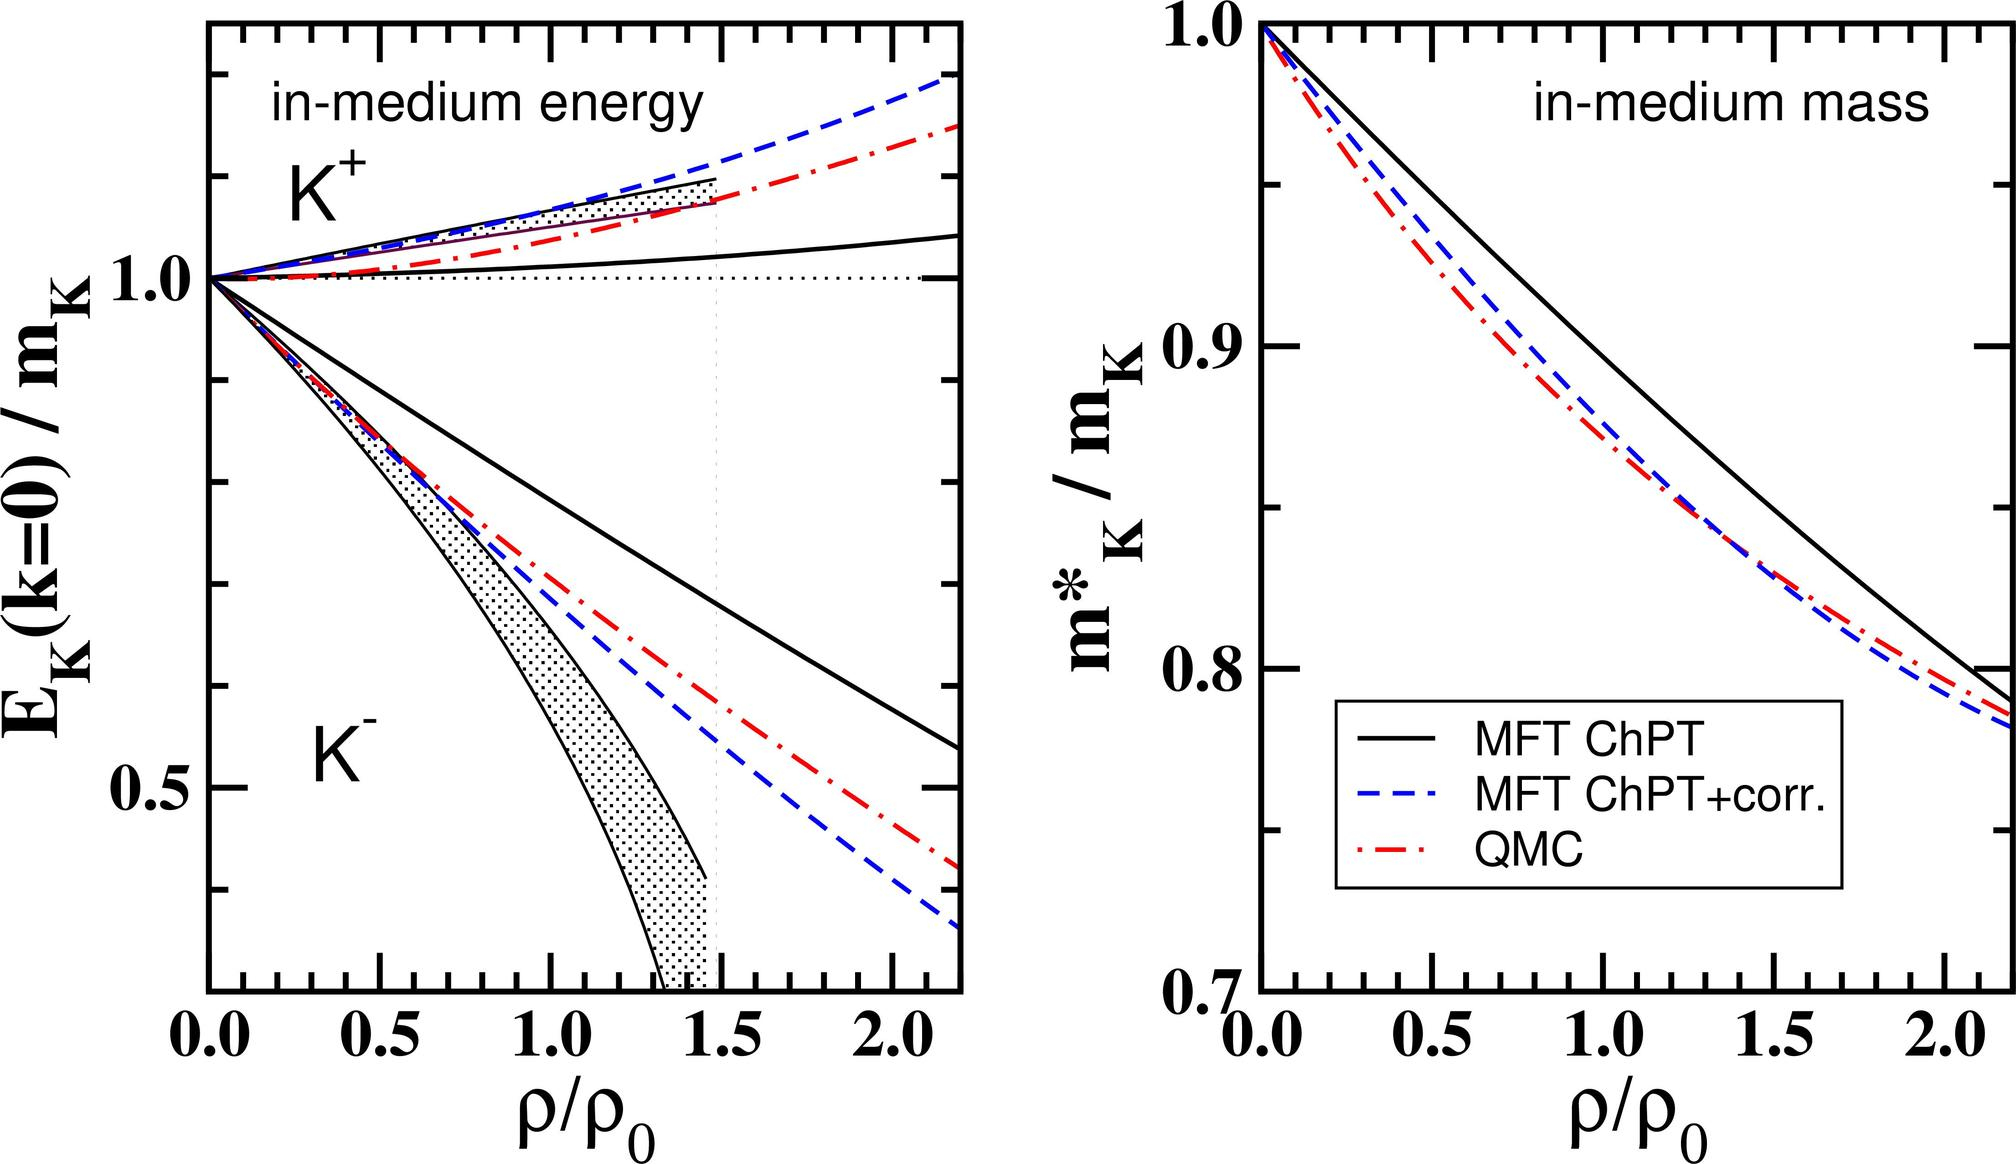Which model, according to the right graph, predicts the smallest decrease in the \( K^+ \) meson mass in the medium at twice the standard nuclear density (\( 2\rho_0 \))? A. Mean Field Theory (MFT) Chiral Perturbation Theory (ChPT) B. MFT ChPT with corrections (corr.) C. Quark-Meson Coupling (QMC) D. The models predict the same decrease in \( K^+ \) meson mass at \( 2\rho_0 \). Based on the graphical data from the right graph titled 'in-medium mass', at \( \rho/\rho_0 = 2 \), the Mass of \( K^+ \) according to Mean Field Theory with Chiral Perturbation Theory (solid black line) depicts it remains closest to its original mass when compared to other theories. The graph shows this line lies highest at this nuclear density level, suggesting that this theory predicts the smallest decrease in meson mass under these conditions. Therefore, the correct answer is A. Mean Field Theory (MFT) Chiral Perturbation Theory (ChPT). This insight is pivotal for understanding predictions on meson behavior in high-density environments, an essential aspect in nuclear physics and astrophysics research. 